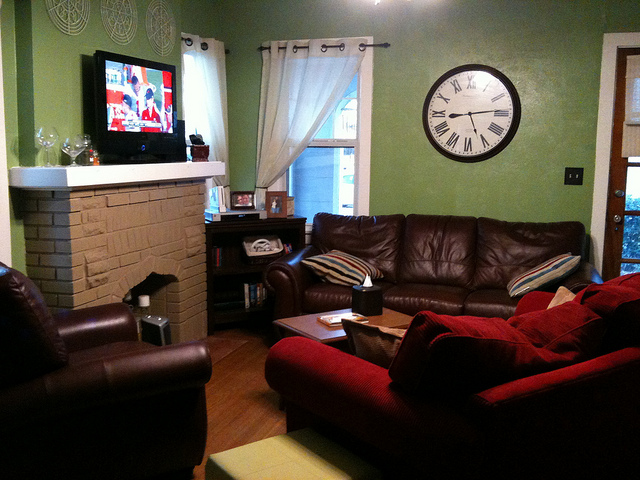Identify the text contained in this image. XI X IX VIII VII V 